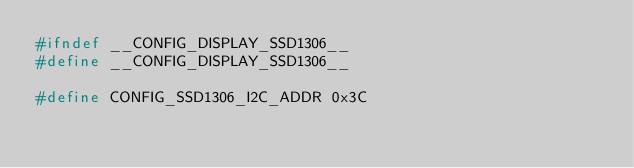<code> <loc_0><loc_0><loc_500><loc_500><_C_>#ifndef __CONFIG_DISPLAY_SSD1306__
#define __CONFIG_DISPLAY_SSD1306__

#define CONFIG_SSD1306_I2C_ADDR 0x3C</code> 